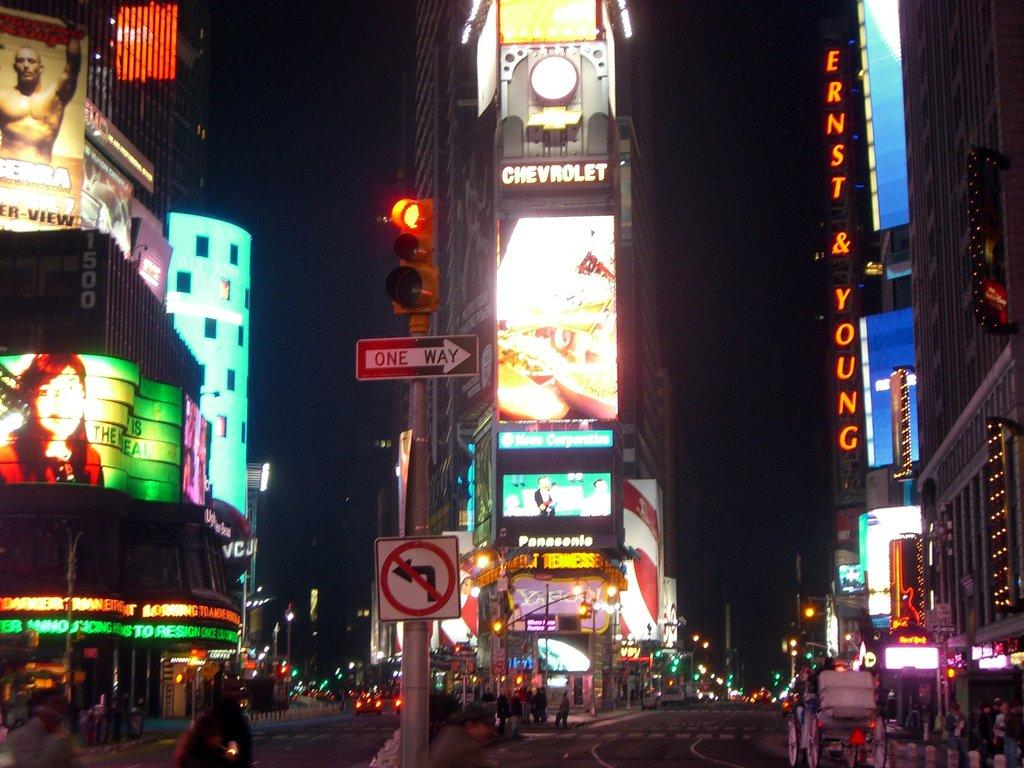<image>
Share a concise interpretation of the image provided. Many bright signs are lit up, including one that says Ernst Young and one for Panasonic. 